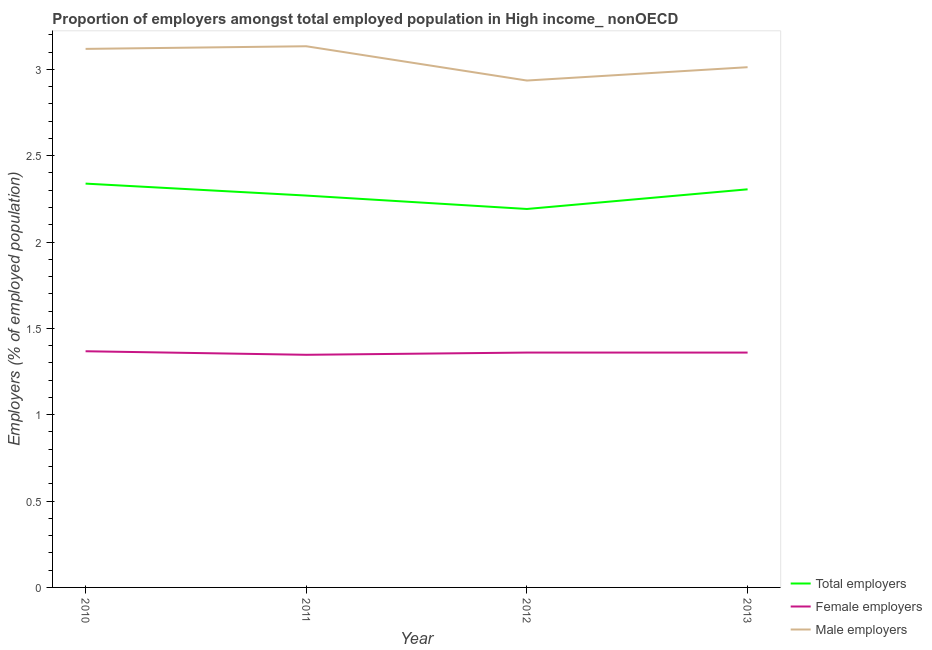How many different coloured lines are there?
Keep it short and to the point. 3. Does the line corresponding to percentage of male employers intersect with the line corresponding to percentage of total employers?
Keep it short and to the point. No. Is the number of lines equal to the number of legend labels?
Offer a very short reply. Yes. What is the percentage of male employers in 2011?
Give a very brief answer. 3.13. Across all years, what is the maximum percentage of female employers?
Your response must be concise. 1.37. Across all years, what is the minimum percentage of total employers?
Your response must be concise. 2.19. What is the total percentage of male employers in the graph?
Give a very brief answer. 12.2. What is the difference between the percentage of female employers in 2011 and that in 2013?
Your answer should be very brief. -0.01. What is the difference between the percentage of total employers in 2013 and the percentage of male employers in 2010?
Keep it short and to the point. -0.81. What is the average percentage of male employers per year?
Make the answer very short. 3.05. In the year 2010, what is the difference between the percentage of total employers and percentage of female employers?
Provide a short and direct response. 0.97. In how many years, is the percentage of male employers greater than 0.5 %?
Your answer should be very brief. 4. What is the ratio of the percentage of female employers in 2010 to that in 2011?
Make the answer very short. 1.02. What is the difference between the highest and the second highest percentage of female employers?
Ensure brevity in your answer.  0.01. What is the difference between the highest and the lowest percentage of total employers?
Offer a terse response. 0.15. In how many years, is the percentage of male employers greater than the average percentage of male employers taken over all years?
Provide a succinct answer. 2. Is the sum of the percentage of total employers in 2011 and 2012 greater than the maximum percentage of female employers across all years?
Keep it short and to the point. Yes. Does the percentage of male employers monotonically increase over the years?
Provide a short and direct response. No. Is the percentage of total employers strictly greater than the percentage of female employers over the years?
Give a very brief answer. Yes. Is the percentage of total employers strictly less than the percentage of female employers over the years?
Your response must be concise. No. How many years are there in the graph?
Offer a terse response. 4. Are the values on the major ticks of Y-axis written in scientific E-notation?
Your answer should be compact. No. Does the graph contain any zero values?
Offer a very short reply. No. How are the legend labels stacked?
Offer a very short reply. Vertical. What is the title of the graph?
Give a very brief answer. Proportion of employers amongst total employed population in High income_ nonOECD. What is the label or title of the Y-axis?
Offer a terse response. Employers (% of employed population). What is the Employers (% of employed population) in Total employers in 2010?
Your response must be concise. 2.34. What is the Employers (% of employed population) in Female employers in 2010?
Offer a terse response. 1.37. What is the Employers (% of employed population) in Male employers in 2010?
Keep it short and to the point. 3.12. What is the Employers (% of employed population) of Total employers in 2011?
Offer a very short reply. 2.27. What is the Employers (% of employed population) of Female employers in 2011?
Your response must be concise. 1.35. What is the Employers (% of employed population) of Male employers in 2011?
Your response must be concise. 3.13. What is the Employers (% of employed population) in Total employers in 2012?
Offer a very short reply. 2.19. What is the Employers (% of employed population) of Female employers in 2012?
Your response must be concise. 1.36. What is the Employers (% of employed population) of Male employers in 2012?
Provide a short and direct response. 2.94. What is the Employers (% of employed population) of Total employers in 2013?
Provide a succinct answer. 2.31. What is the Employers (% of employed population) in Female employers in 2013?
Make the answer very short. 1.36. What is the Employers (% of employed population) in Male employers in 2013?
Give a very brief answer. 3.01. Across all years, what is the maximum Employers (% of employed population) of Total employers?
Keep it short and to the point. 2.34. Across all years, what is the maximum Employers (% of employed population) of Female employers?
Offer a very short reply. 1.37. Across all years, what is the maximum Employers (% of employed population) in Male employers?
Your response must be concise. 3.13. Across all years, what is the minimum Employers (% of employed population) of Total employers?
Your answer should be very brief. 2.19. Across all years, what is the minimum Employers (% of employed population) in Female employers?
Offer a very short reply. 1.35. Across all years, what is the minimum Employers (% of employed population) in Male employers?
Give a very brief answer. 2.94. What is the total Employers (% of employed population) of Total employers in the graph?
Your response must be concise. 9.1. What is the total Employers (% of employed population) in Female employers in the graph?
Make the answer very short. 5.43. What is the total Employers (% of employed population) of Male employers in the graph?
Your answer should be very brief. 12.2. What is the difference between the Employers (% of employed population) of Total employers in 2010 and that in 2011?
Offer a very short reply. 0.07. What is the difference between the Employers (% of employed population) in Female employers in 2010 and that in 2011?
Give a very brief answer. 0.02. What is the difference between the Employers (% of employed population) of Male employers in 2010 and that in 2011?
Provide a succinct answer. -0.02. What is the difference between the Employers (% of employed population) of Total employers in 2010 and that in 2012?
Your response must be concise. 0.15. What is the difference between the Employers (% of employed population) in Female employers in 2010 and that in 2012?
Your answer should be compact. 0.01. What is the difference between the Employers (% of employed population) of Male employers in 2010 and that in 2012?
Provide a short and direct response. 0.18. What is the difference between the Employers (% of employed population) of Total employers in 2010 and that in 2013?
Keep it short and to the point. 0.03. What is the difference between the Employers (% of employed population) of Female employers in 2010 and that in 2013?
Make the answer very short. 0.01. What is the difference between the Employers (% of employed population) of Male employers in 2010 and that in 2013?
Offer a terse response. 0.11. What is the difference between the Employers (% of employed population) of Total employers in 2011 and that in 2012?
Provide a succinct answer. 0.08. What is the difference between the Employers (% of employed population) in Female employers in 2011 and that in 2012?
Ensure brevity in your answer.  -0.01. What is the difference between the Employers (% of employed population) of Male employers in 2011 and that in 2012?
Your response must be concise. 0.2. What is the difference between the Employers (% of employed population) of Total employers in 2011 and that in 2013?
Provide a succinct answer. -0.04. What is the difference between the Employers (% of employed population) of Female employers in 2011 and that in 2013?
Offer a very short reply. -0.01. What is the difference between the Employers (% of employed population) of Male employers in 2011 and that in 2013?
Keep it short and to the point. 0.12. What is the difference between the Employers (% of employed population) of Total employers in 2012 and that in 2013?
Offer a very short reply. -0.11. What is the difference between the Employers (% of employed population) in Male employers in 2012 and that in 2013?
Make the answer very short. -0.08. What is the difference between the Employers (% of employed population) of Total employers in 2010 and the Employers (% of employed population) of Female employers in 2011?
Give a very brief answer. 0.99. What is the difference between the Employers (% of employed population) in Total employers in 2010 and the Employers (% of employed population) in Male employers in 2011?
Your answer should be very brief. -0.8. What is the difference between the Employers (% of employed population) of Female employers in 2010 and the Employers (% of employed population) of Male employers in 2011?
Your answer should be very brief. -1.77. What is the difference between the Employers (% of employed population) of Total employers in 2010 and the Employers (% of employed population) of Female employers in 2012?
Keep it short and to the point. 0.98. What is the difference between the Employers (% of employed population) of Total employers in 2010 and the Employers (% of employed population) of Male employers in 2012?
Your answer should be compact. -0.6. What is the difference between the Employers (% of employed population) of Female employers in 2010 and the Employers (% of employed population) of Male employers in 2012?
Offer a very short reply. -1.57. What is the difference between the Employers (% of employed population) in Total employers in 2010 and the Employers (% of employed population) in Female employers in 2013?
Keep it short and to the point. 0.98. What is the difference between the Employers (% of employed population) in Total employers in 2010 and the Employers (% of employed population) in Male employers in 2013?
Ensure brevity in your answer.  -0.67. What is the difference between the Employers (% of employed population) of Female employers in 2010 and the Employers (% of employed population) of Male employers in 2013?
Make the answer very short. -1.64. What is the difference between the Employers (% of employed population) in Total employers in 2011 and the Employers (% of employed population) in Female employers in 2012?
Offer a terse response. 0.91. What is the difference between the Employers (% of employed population) of Total employers in 2011 and the Employers (% of employed population) of Male employers in 2012?
Offer a very short reply. -0.67. What is the difference between the Employers (% of employed population) of Female employers in 2011 and the Employers (% of employed population) of Male employers in 2012?
Your response must be concise. -1.59. What is the difference between the Employers (% of employed population) of Total employers in 2011 and the Employers (% of employed population) of Female employers in 2013?
Provide a succinct answer. 0.91. What is the difference between the Employers (% of employed population) in Total employers in 2011 and the Employers (% of employed population) in Male employers in 2013?
Give a very brief answer. -0.74. What is the difference between the Employers (% of employed population) of Female employers in 2011 and the Employers (% of employed population) of Male employers in 2013?
Provide a short and direct response. -1.67. What is the difference between the Employers (% of employed population) in Total employers in 2012 and the Employers (% of employed population) in Female employers in 2013?
Offer a very short reply. 0.83. What is the difference between the Employers (% of employed population) of Total employers in 2012 and the Employers (% of employed population) of Male employers in 2013?
Provide a succinct answer. -0.82. What is the difference between the Employers (% of employed population) in Female employers in 2012 and the Employers (% of employed population) in Male employers in 2013?
Your answer should be compact. -1.65. What is the average Employers (% of employed population) in Total employers per year?
Your answer should be compact. 2.28. What is the average Employers (% of employed population) in Female employers per year?
Provide a short and direct response. 1.36. What is the average Employers (% of employed population) of Male employers per year?
Provide a short and direct response. 3.05. In the year 2010, what is the difference between the Employers (% of employed population) of Total employers and Employers (% of employed population) of Female employers?
Your answer should be very brief. 0.97. In the year 2010, what is the difference between the Employers (% of employed population) in Total employers and Employers (% of employed population) in Male employers?
Make the answer very short. -0.78. In the year 2010, what is the difference between the Employers (% of employed population) of Female employers and Employers (% of employed population) of Male employers?
Make the answer very short. -1.75. In the year 2011, what is the difference between the Employers (% of employed population) of Total employers and Employers (% of employed population) of Female employers?
Your response must be concise. 0.92. In the year 2011, what is the difference between the Employers (% of employed population) of Total employers and Employers (% of employed population) of Male employers?
Give a very brief answer. -0.86. In the year 2011, what is the difference between the Employers (% of employed population) of Female employers and Employers (% of employed population) of Male employers?
Your answer should be compact. -1.79. In the year 2012, what is the difference between the Employers (% of employed population) in Total employers and Employers (% of employed population) in Female employers?
Keep it short and to the point. 0.83. In the year 2012, what is the difference between the Employers (% of employed population) in Total employers and Employers (% of employed population) in Male employers?
Keep it short and to the point. -0.74. In the year 2012, what is the difference between the Employers (% of employed population) in Female employers and Employers (% of employed population) in Male employers?
Give a very brief answer. -1.58. In the year 2013, what is the difference between the Employers (% of employed population) in Total employers and Employers (% of employed population) in Female employers?
Ensure brevity in your answer.  0.95. In the year 2013, what is the difference between the Employers (% of employed population) in Total employers and Employers (% of employed population) in Male employers?
Your answer should be compact. -0.71. In the year 2013, what is the difference between the Employers (% of employed population) in Female employers and Employers (% of employed population) in Male employers?
Your response must be concise. -1.65. What is the ratio of the Employers (% of employed population) in Total employers in 2010 to that in 2011?
Give a very brief answer. 1.03. What is the ratio of the Employers (% of employed population) of Female employers in 2010 to that in 2011?
Provide a succinct answer. 1.02. What is the ratio of the Employers (% of employed population) of Total employers in 2010 to that in 2012?
Offer a terse response. 1.07. What is the ratio of the Employers (% of employed population) of Female employers in 2010 to that in 2012?
Your answer should be very brief. 1.01. What is the ratio of the Employers (% of employed population) in Male employers in 2010 to that in 2012?
Your answer should be compact. 1.06. What is the ratio of the Employers (% of employed population) of Total employers in 2010 to that in 2013?
Your answer should be very brief. 1.01. What is the ratio of the Employers (% of employed population) of Male employers in 2010 to that in 2013?
Provide a succinct answer. 1.04. What is the ratio of the Employers (% of employed population) in Total employers in 2011 to that in 2012?
Ensure brevity in your answer.  1.04. What is the ratio of the Employers (% of employed population) in Male employers in 2011 to that in 2012?
Ensure brevity in your answer.  1.07. What is the ratio of the Employers (% of employed population) in Total employers in 2011 to that in 2013?
Your response must be concise. 0.98. What is the ratio of the Employers (% of employed population) in Female employers in 2011 to that in 2013?
Your answer should be very brief. 0.99. What is the ratio of the Employers (% of employed population) of Male employers in 2011 to that in 2013?
Offer a terse response. 1.04. What is the ratio of the Employers (% of employed population) in Total employers in 2012 to that in 2013?
Provide a short and direct response. 0.95. What is the ratio of the Employers (% of employed population) of Female employers in 2012 to that in 2013?
Offer a terse response. 1. What is the ratio of the Employers (% of employed population) of Male employers in 2012 to that in 2013?
Keep it short and to the point. 0.97. What is the difference between the highest and the second highest Employers (% of employed population) in Total employers?
Give a very brief answer. 0.03. What is the difference between the highest and the second highest Employers (% of employed population) of Female employers?
Your response must be concise. 0.01. What is the difference between the highest and the second highest Employers (% of employed population) of Male employers?
Offer a very short reply. 0.02. What is the difference between the highest and the lowest Employers (% of employed population) in Total employers?
Your answer should be very brief. 0.15. What is the difference between the highest and the lowest Employers (% of employed population) of Female employers?
Give a very brief answer. 0.02. What is the difference between the highest and the lowest Employers (% of employed population) in Male employers?
Offer a very short reply. 0.2. 